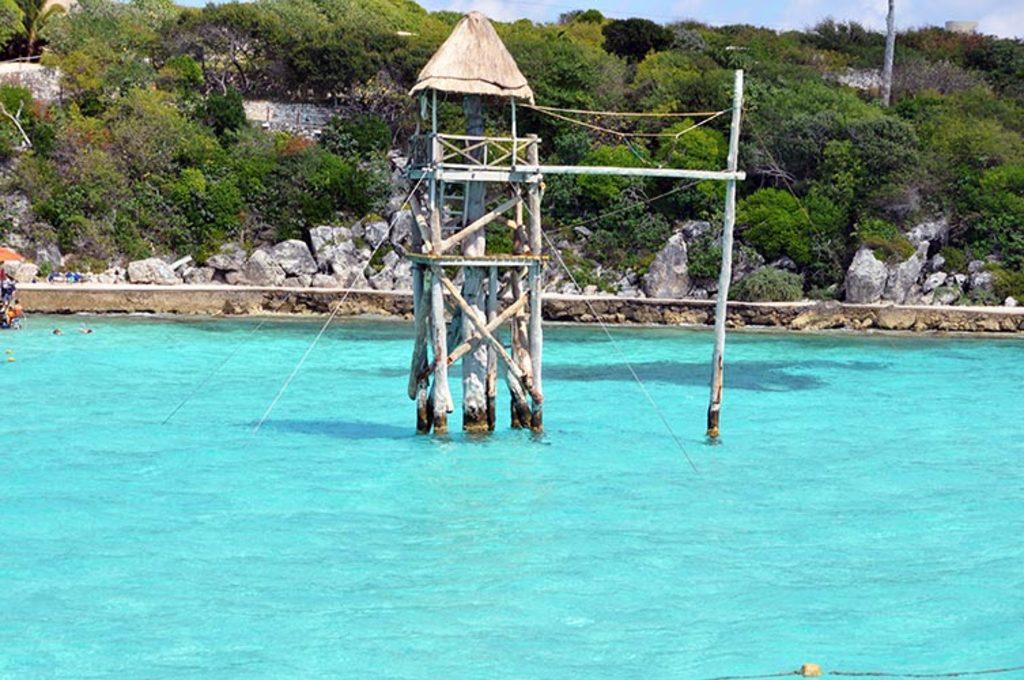What is present in the image that is liquid? There is water in the image. What type of shelter can be seen in the image? There is a hut in the image. What can be seen in the distance behind the hut? There are trees in the background of the image. What is visible in the sky in the background of the image? There are clouds in the sky in the background of the image. What color of paint is being used on the hen in the image? There is no hen present in the image, so there is no paint to consider. How many chickens are visible in the image? There are no chickens present in the image. 